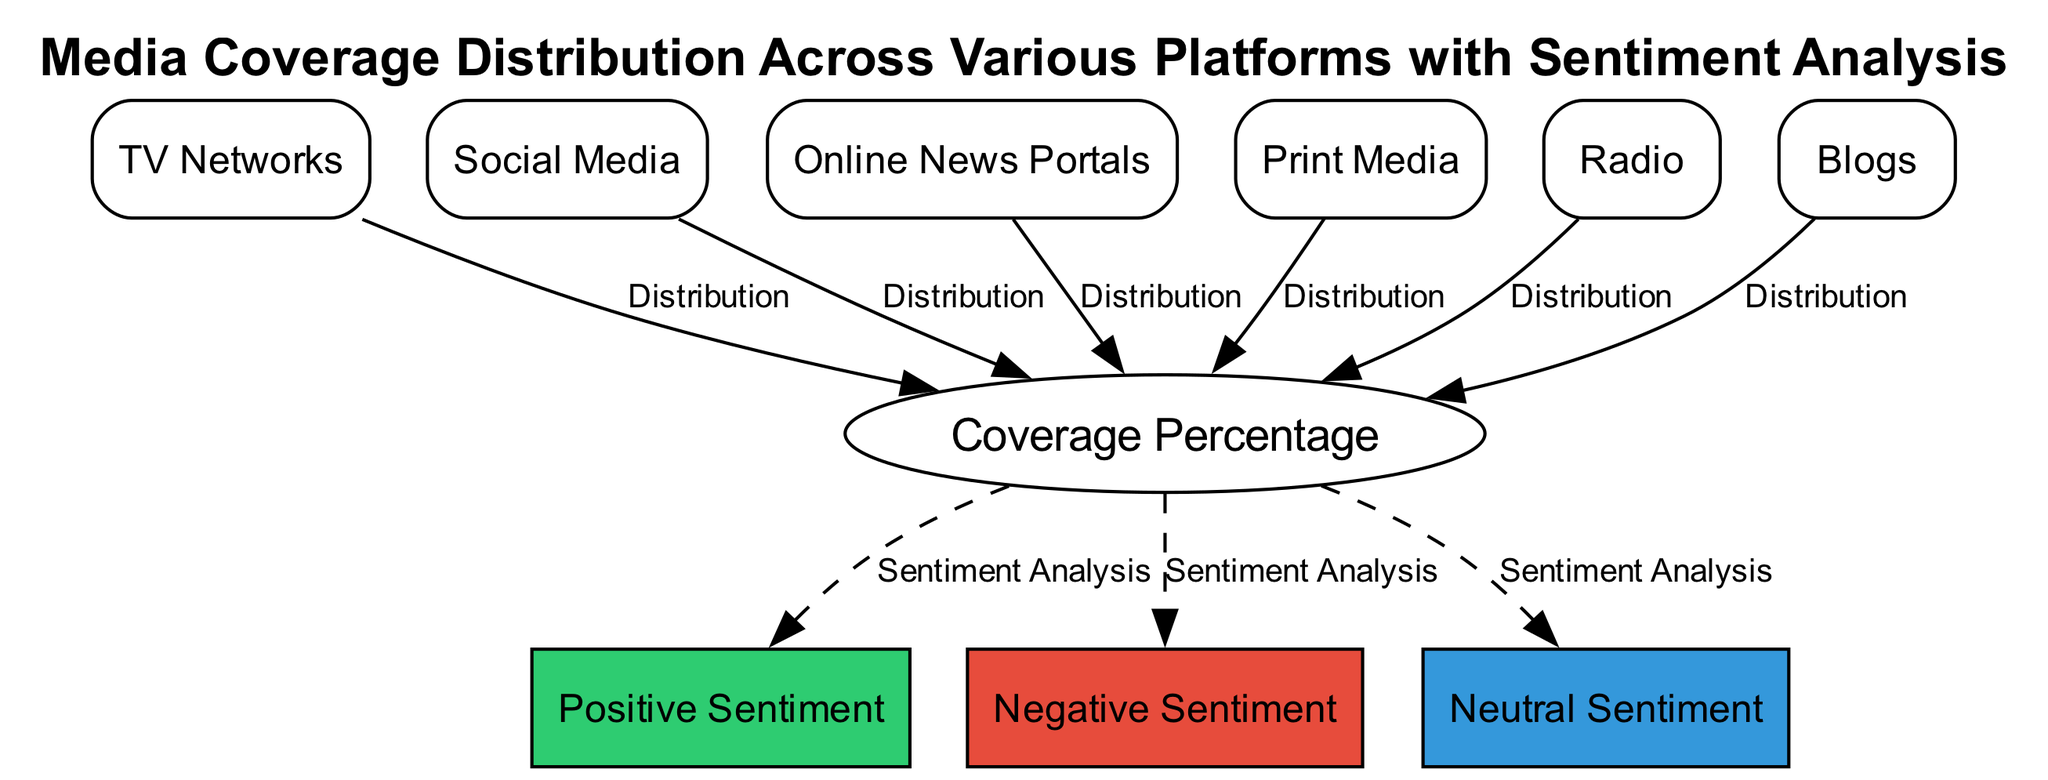What are the four media platforms listed in this diagram? The diagram lists TV Networks, Social Media, Online News Portals, and Print Media as the four media platforms. Each platform is represented as a separate node, explicitly labeled in the diagram.
Answer: TV Networks, Social Media, Online News Portals, Print Media What type of media is associated with NPR and Talk Radio? NPR and Talk Radio are categorized under the node labeled "Radio." The diagram explicitly describes this group of media, identifying them with their respective affiliation.
Answer: Radio How many total nodes are present in the diagram? The diagram contains ten nodes in total. This includes all media platforms, the coverage percentage node, and the sentiment analysis nodes.
Answer: 10 What sentiment analysis categories are depicted in the diagram? The categories indicated in the diagram for sentiment analysis are Positive Sentiment, Negative Sentiment, and Neutral Sentiment. These are shown as distinct nodes connected to the coverage percentage node.
Answer: Positive Sentiment, Negative Sentiment, Neutral Sentiment Which media platform shows the highest coverage percentage in the diagram? To determine the highest coverage percentage among the platforms, one must reference the individual distributions associated with each media type. This specific detail isn’t visualized directly here but would typically require analyzing the diagram or data associated with it.
Answer: [Coverage percentage detail not provided in the data.] Which media platforms are linked to the coverage percentage node? The media platforms linked to the coverage percentage node are TV Networks, Social Media, Online News Portals, Print Media, Radio, and Blogs. Each of these nodes connects to the coverage percentage, showing their distribution in the media landscape.
Answer: TV Networks, Social Media, Online News Portals, Print Media, Radio, Blogs How many sentiment types are analyzed from the coverage percentage? There are three sentiment types analyzed from the coverage percentage: Positive Sentiment, Negative Sentiment, and Neutral Sentiment. Each is connected directly to the coverage percentage node, indicating the categorization of the coverage tone.
Answer: 3 What process connects media coverage to sentiment analysis in the diagram? The process connecting media coverage to sentiment analysis in the diagram is shown through a series of connections. Each media platform connects to the coverage percentage, which then branches out to the sentiment analysis categories, indicating that the coverage tone is derived from the distribution of media coverage.
Answer: Distribution to Sentiment Analysis 